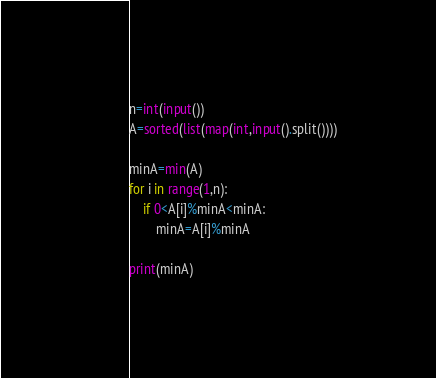<code> <loc_0><loc_0><loc_500><loc_500><_Python_>n=int(input())
A=sorted(list(map(int,input().split())))

minA=min(A)
for i in range(1,n):
    if 0<A[i]%minA<minA:
        minA=A[i]%minA

print(minA)</code> 